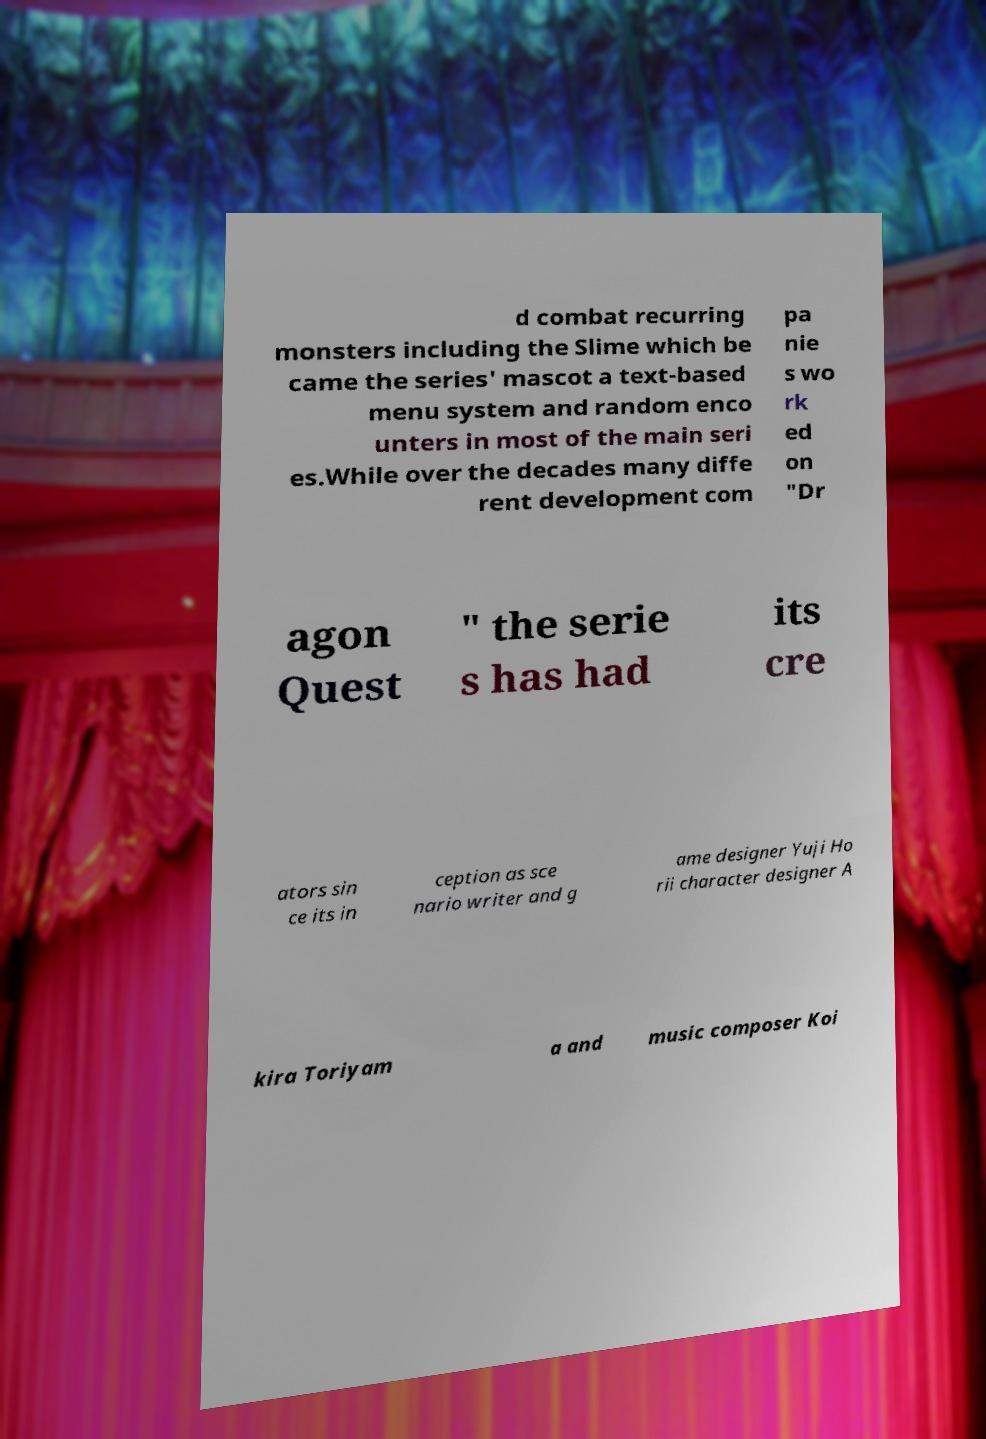There's text embedded in this image that I need extracted. Can you transcribe it verbatim? d combat recurring monsters including the Slime which be came the series' mascot a text-based menu system and random enco unters in most of the main seri es.While over the decades many diffe rent development com pa nie s wo rk ed on "Dr agon Quest " the serie s has had its cre ators sin ce its in ception as sce nario writer and g ame designer Yuji Ho rii character designer A kira Toriyam a and music composer Koi 